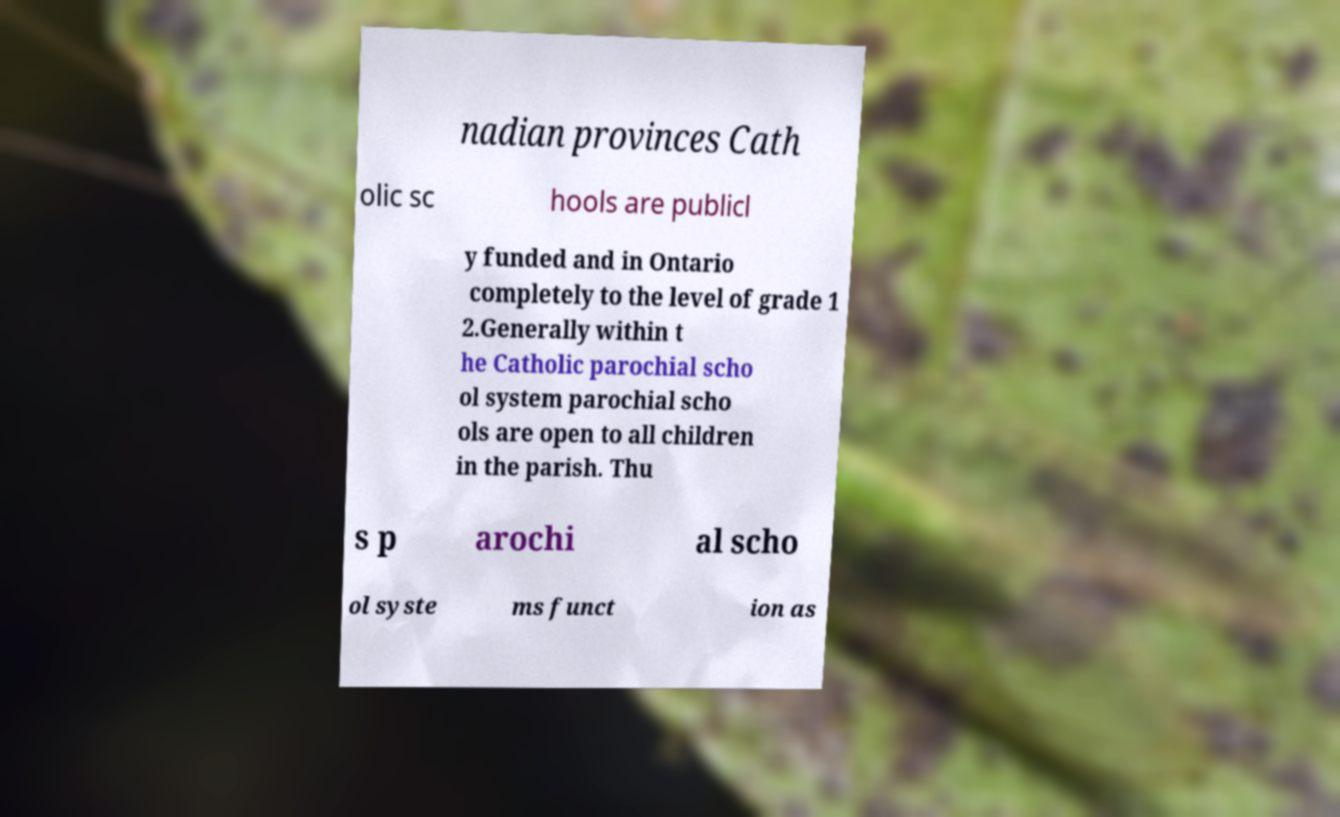I need the written content from this picture converted into text. Can you do that? nadian provinces Cath olic sc hools are publicl y funded and in Ontario completely to the level of grade 1 2.Generally within t he Catholic parochial scho ol system parochial scho ols are open to all children in the parish. Thu s p arochi al scho ol syste ms funct ion as 